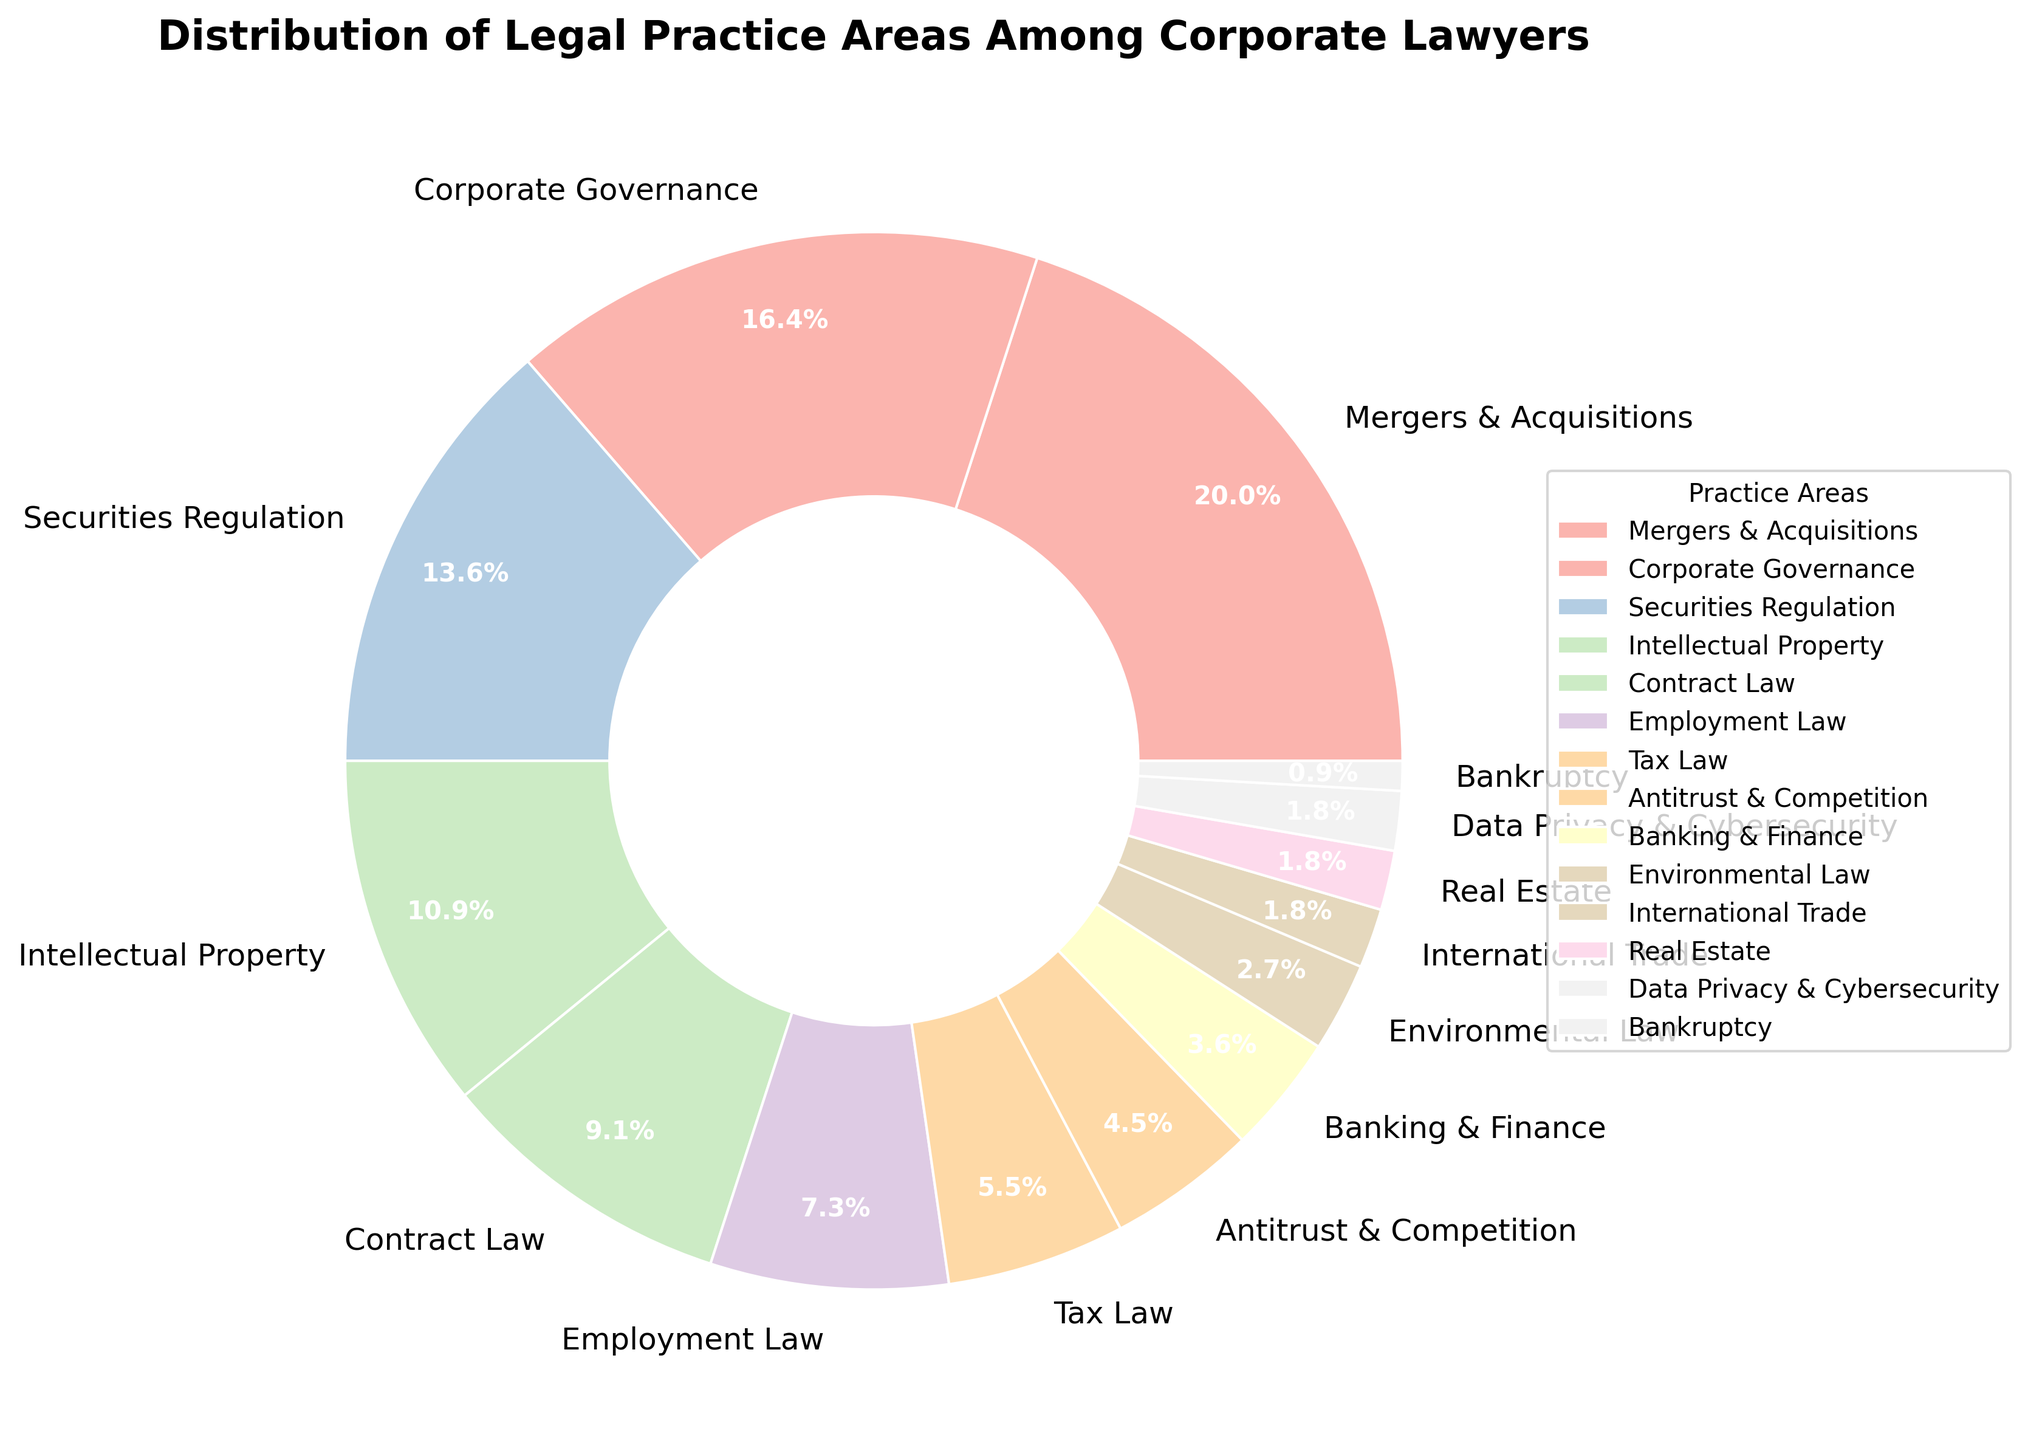what percentage of corporate lawyers specialize in Mergers & Acquisitions? Mergers & Acquisitions segment occupies 22% of the pie chart
Answer: 22% which legal practice area has the smallest representation among corporate lawyers? Bankruptcy has the smallest segment in the pie chart at 1%
Answer: Bankruptcy how does the percentage of Corporate Governance compare to that of Securities Regulation? Corporate Governance occupies 18% of the pie while Securities Regulation occupies 15%
Answer: Corporate Governance is 3% more what is the combined percentage of legal practice areas less than 5%? Summing the percentages: (Banking & Finance 4% + Environmental Law 3% + International Trade 2% + Real Estate 2% + Data Privacy & Cybersecurity 2% + Bankruptcy 1%) = 14%
Answer: 14% how much larger is the Mergers & Acquisitions sector compared to the Contract Law sector? Subtract the percentage of Contract Law (10%) from Mergers & Acquisitions (22%) = 22% - 10% = 12%
Answer: 12% which is greater, the percentage of Employment Law or the combined percentage of Tax Law and Antitrust & Competition? Employment Law is 8%. Combined percentage of Tax Law (6%) and Antitrust & Competition (5%) = 6% + 5% = 11%
Answer: combined percentage of Tax Law and Antitrust & Competition what is the total percentage of legal practice areas represented in the pie chart? Sum of each percentage equals 100%
Answer: 100% do Intellectual Property and Contract Law combined have a greater percentage than Mergers & Acquisitions alone? Combine percentages of Intellectual Property (12%) and Contract Law (10%) = 12% + 10% = 22%, which is equal to Mergers & Acquisitions' 22%
Answer: equal what is the largest practice area aside from Mergers & Acquisitions? The next largest slice after Mergers & Acquisitions (22%) is Corporate Governance (18%)
Answer: Corporate Governance how many practice areas have a percentage of 10% or more? Areas meeting criteria are Mergers & Acquisitions (22%), Corporate Governance (18%), Securities Regulation (15%), Intellectual Property (12%), and Contract Law (10%). Total = 5
Answer: 5 